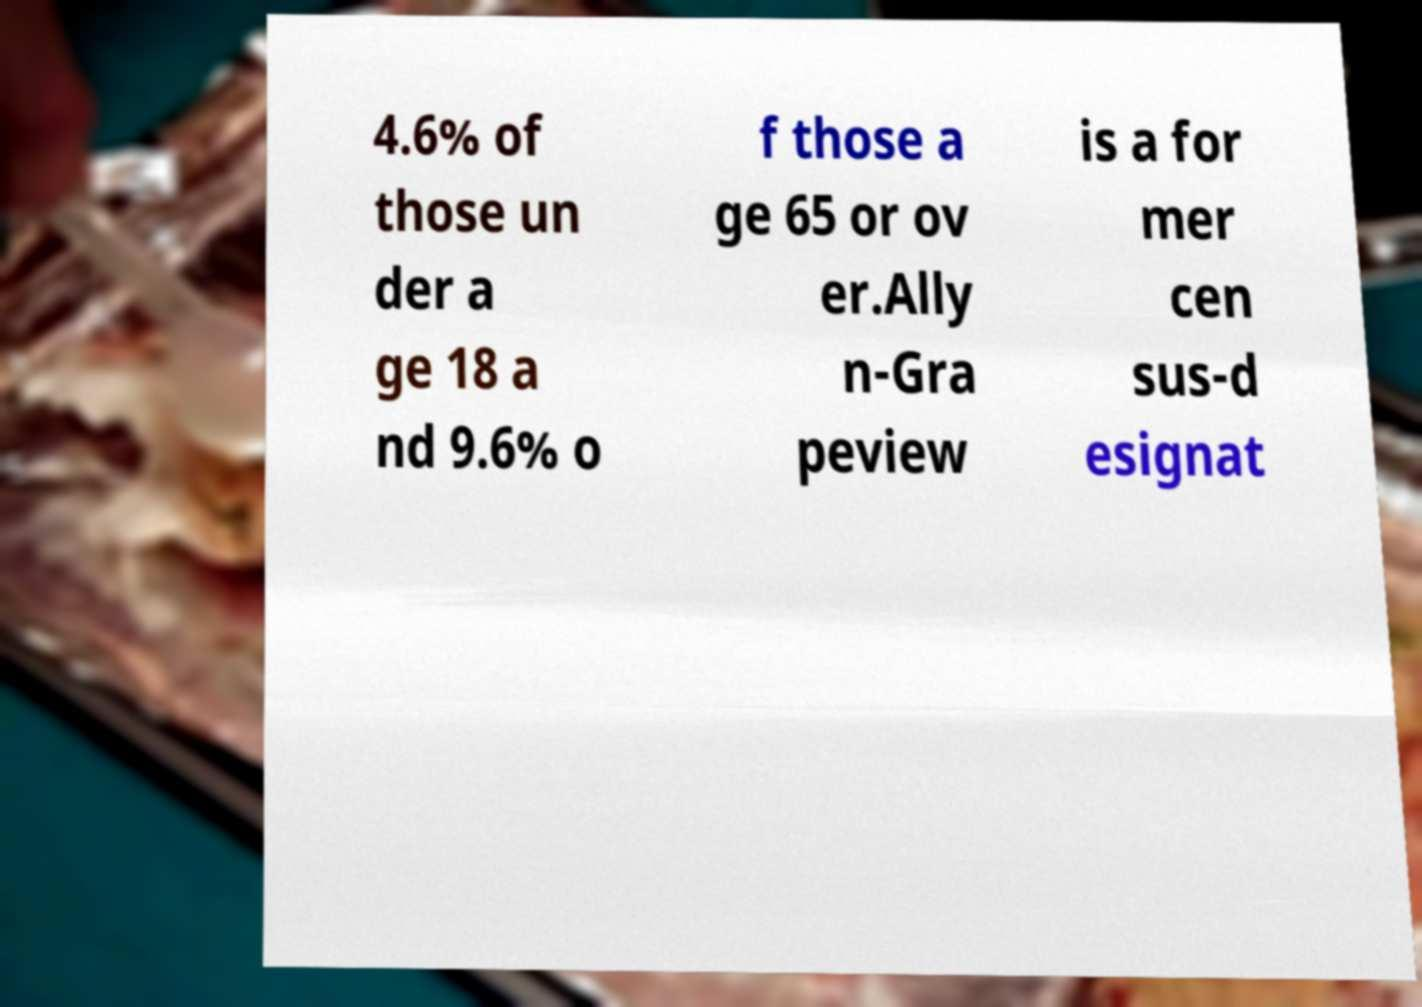Could you assist in decoding the text presented in this image and type it out clearly? 4.6% of those un der a ge 18 a nd 9.6% o f those a ge 65 or ov er.Ally n-Gra peview is a for mer cen sus-d esignat 